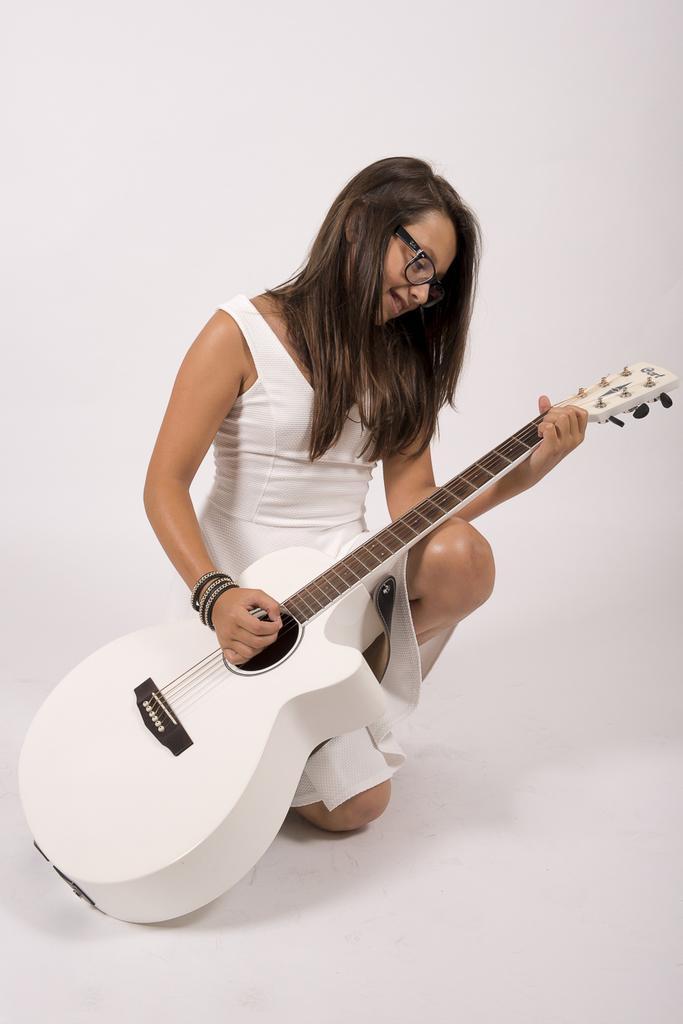Please provide a concise description of this image. This is a picture of a woman in white dress holding a white guitar. background of this woman is a wall which is in white color. 